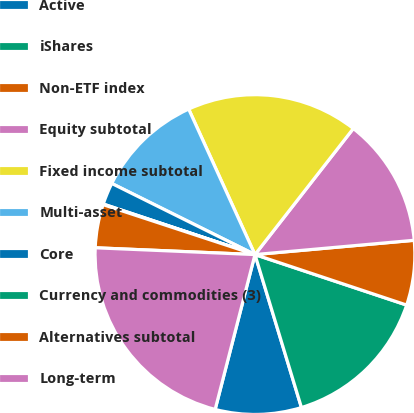Convert chart to OTSL. <chart><loc_0><loc_0><loc_500><loc_500><pie_chart><fcel>Active<fcel>iShares<fcel>Non-ETF index<fcel>Equity subtotal<fcel>Fixed income subtotal<fcel>Multi-asset<fcel>Core<fcel>Currency and commodities (3)<fcel>Alternatives subtotal<fcel>Long-term<nl><fcel>8.7%<fcel>15.19%<fcel>6.54%<fcel>13.03%<fcel>17.35%<fcel>10.86%<fcel>2.22%<fcel>0.06%<fcel>4.38%<fcel>21.67%<nl></chart> 